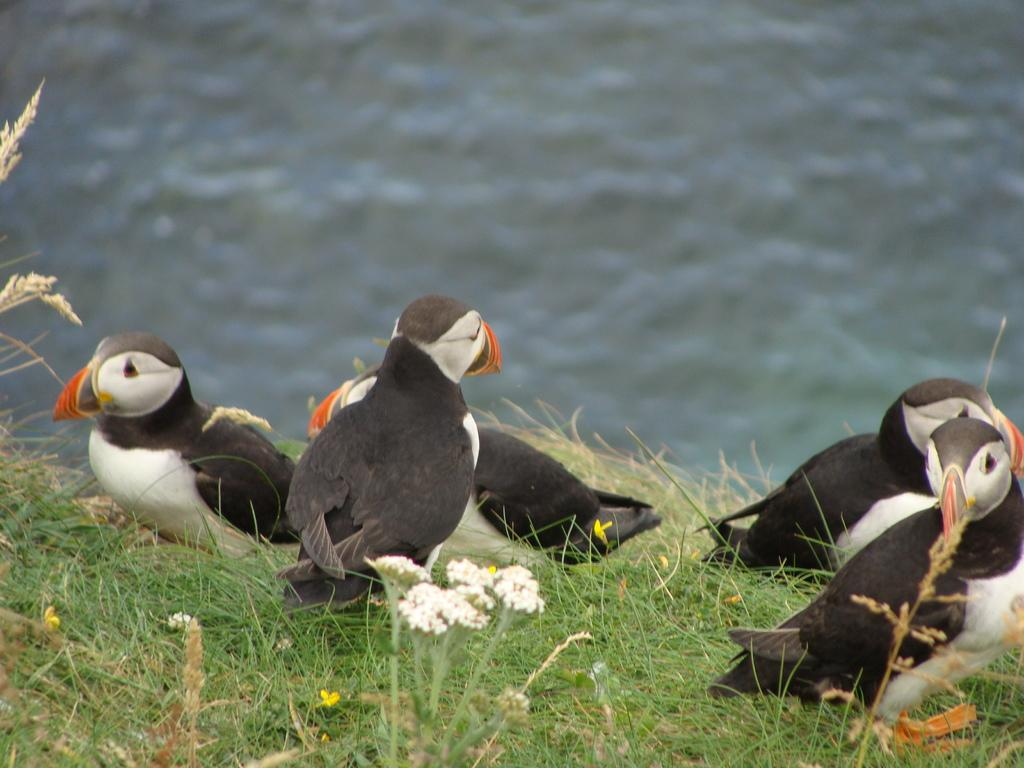What type of birds are in the center of the image? There are Atlantic puffins in the center of the image. What type of vegetation is at the bottom of the image? There is grass and flowers at the bottom of the image. What is visible at the top of the image? There is water visible at the top of the image. What type of cord is being used by the puffins to communicate in the image? There is no cord present in the image, and the puffins do not communicate using cords. 